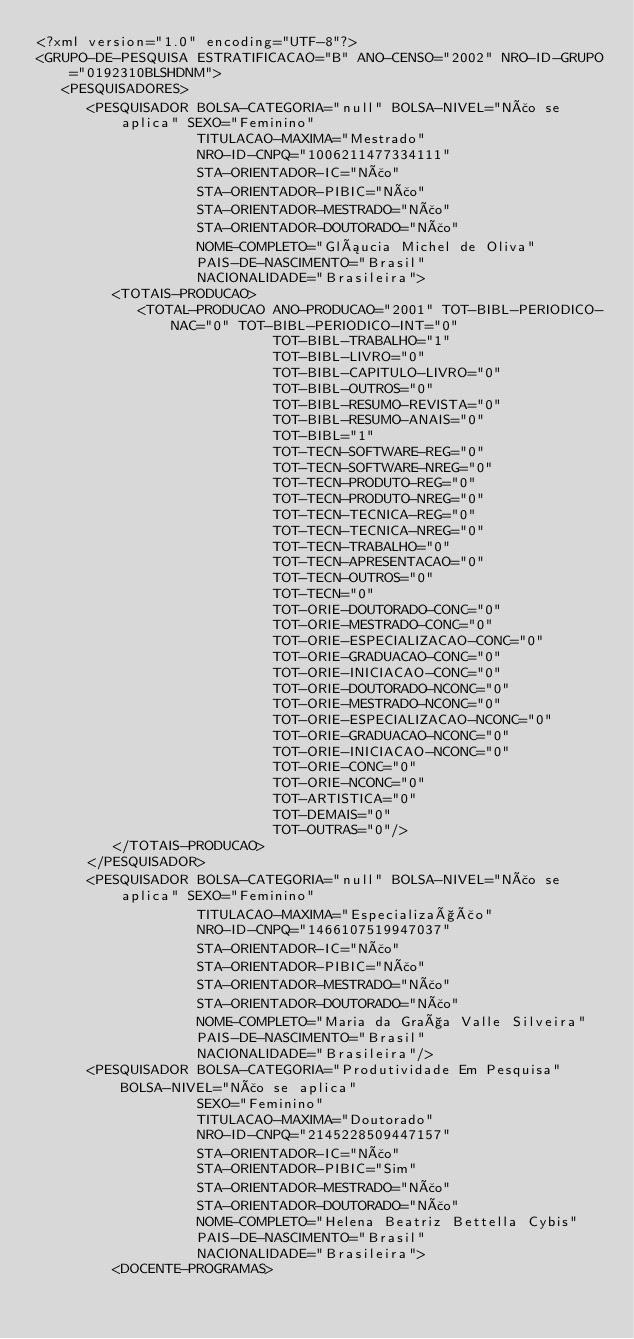Convert code to text. <code><loc_0><loc_0><loc_500><loc_500><_XML_><?xml version="1.0" encoding="UTF-8"?>
<GRUPO-DE-PESQUISA ESTRATIFICACAO="B" ANO-CENSO="2002" NRO-ID-GRUPO="0192310BLSHDNM">
   <PESQUISADORES>
      <PESQUISADOR BOLSA-CATEGORIA="null" BOLSA-NIVEL="Não se aplica" SEXO="Feminino"
                   TITULACAO-MAXIMA="Mestrado"
                   NRO-ID-CNPQ="1006211477334111"
                   STA-ORIENTADOR-IC="Não"
                   STA-ORIENTADOR-PIBIC="Não"
                   STA-ORIENTADOR-MESTRADO="Não"
                   STA-ORIENTADOR-DOUTORADO="Não"
                   NOME-COMPLETO="Gláucia Michel de Oliva"
                   PAIS-DE-NASCIMENTO="Brasil"
                   NACIONALIDADE="Brasileira">
         <TOTAIS-PRODUCAO>
            <TOTAL-PRODUCAO ANO-PRODUCAO="2001" TOT-BIBL-PERIODICO-NAC="0" TOT-BIBL-PERIODICO-INT="0"
                            TOT-BIBL-TRABALHO="1"
                            TOT-BIBL-LIVRO="0"
                            TOT-BIBL-CAPITULO-LIVRO="0"
                            TOT-BIBL-OUTROS="0"
                            TOT-BIBL-RESUMO-REVISTA="0"
                            TOT-BIBL-RESUMO-ANAIS="0"
                            TOT-BIBL="1"
                            TOT-TECN-SOFTWARE-REG="0"
                            TOT-TECN-SOFTWARE-NREG="0"
                            TOT-TECN-PRODUTO-REG="0"
                            TOT-TECN-PRODUTO-NREG="0"
                            TOT-TECN-TECNICA-REG="0"
                            TOT-TECN-TECNICA-NREG="0"
                            TOT-TECN-TRABALHO="0"
                            TOT-TECN-APRESENTACAO="0"
                            TOT-TECN-OUTROS="0"
                            TOT-TECN="0"
                            TOT-ORIE-DOUTORADO-CONC="0"
                            TOT-ORIE-MESTRADO-CONC="0"
                            TOT-ORIE-ESPECIALIZACAO-CONC="0"
                            TOT-ORIE-GRADUACAO-CONC="0"
                            TOT-ORIE-INICIACAO-CONC="0"
                            TOT-ORIE-DOUTORADO-NCONC="0"
                            TOT-ORIE-MESTRADO-NCONC="0"
                            TOT-ORIE-ESPECIALIZACAO-NCONC="0"
                            TOT-ORIE-GRADUACAO-NCONC="0"
                            TOT-ORIE-INICIACAO-NCONC="0"
                            TOT-ORIE-CONC="0"
                            TOT-ORIE-NCONC="0"
                            TOT-ARTISTICA="0"
                            TOT-DEMAIS="0"
                            TOT-OUTRAS="0"/>
         </TOTAIS-PRODUCAO>
      </PESQUISADOR>
      <PESQUISADOR BOLSA-CATEGORIA="null" BOLSA-NIVEL="Não se aplica" SEXO="Feminino"
                   TITULACAO-MAXIMA="Especialização"
                   NRO-ID-CNPQ="1466107519947037"
                   STA-ORIENTADOR-IC="Não"
                   STA-ORIENTADOR-PIBIC="Não"
                   STA-ORIENTADOR-MESTRADO="Não"
                   STA-ORIENTADOR-DOUTORADO="Não"
                   NOME-COMPLETO="Maria da Graça Valle Silveira"
                   PAIS-DE-NASCIMENTO="Brasil"
                   NACIONALIDADE="Brasileira"/>
      <PESQUISADOR BOLSA-CATEGORIA="Produtividade Em Pesquisa" BOLSA-NIVEL="Não se aplica"
                   SEXO="Feminino"
                   TITULACAO-MAXIMA="Doutorado"
                   NRO-ID-CNPQ="2145228509447157"
                   STA-ORIENTADOR-IC="Não"
                   STA-ORIENTADOR-PIBIC="Sim"
                   STA-ORIENTADOR-MESTRADO="Não"
                   STA-ORIENTADOR-DOUTORADO="Não"
                   NOME-COMPLETO="Helena Beatriz Bettella Cybis"
                   PAIS-DE-NASCIMENTO="Brasil"
                   NACIONALIDADE="Brasileira">
         <DOCENTE-PROGRAMAS></code> 